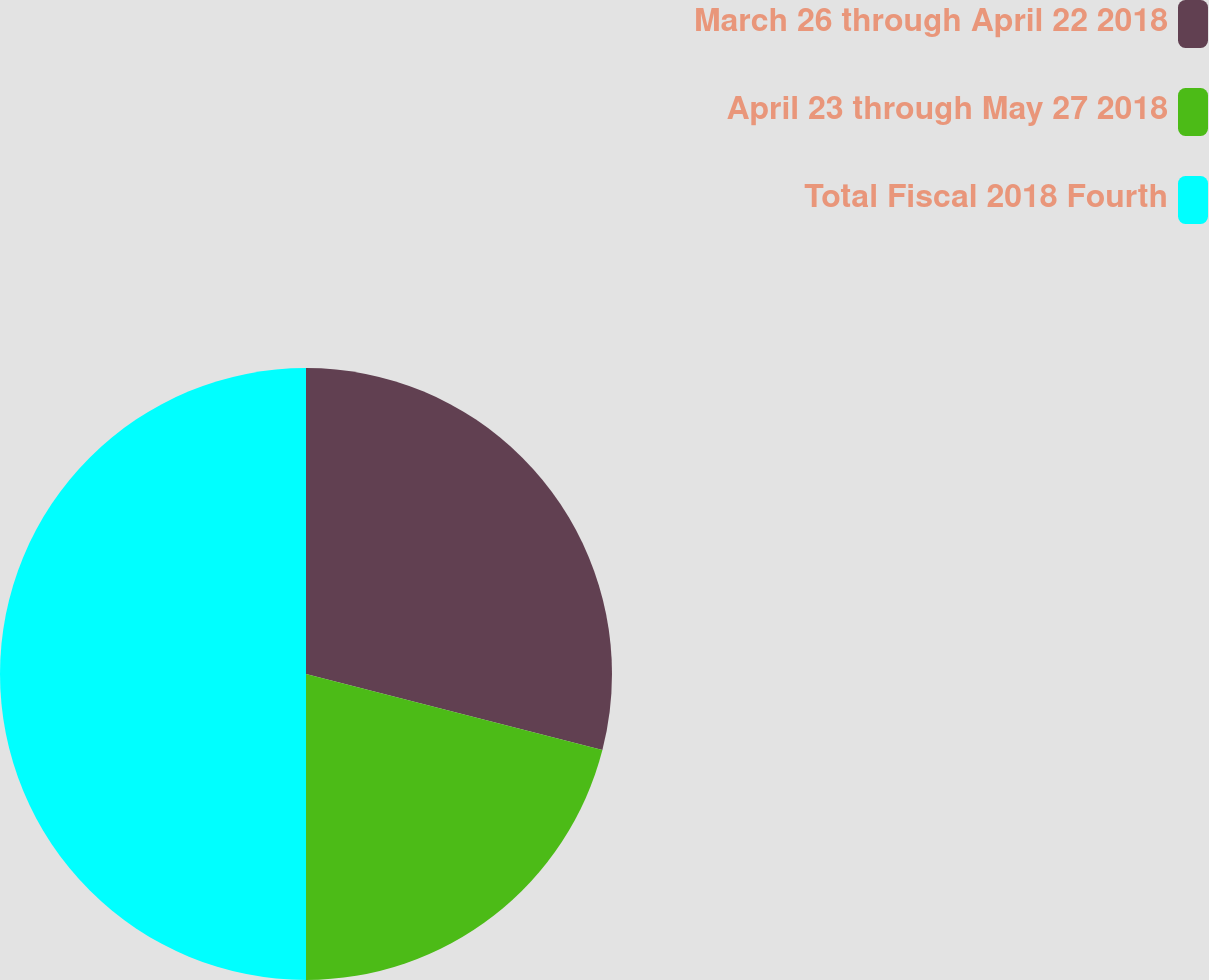<chart> <loc_0><loc_0><loc_500><loc_500><pie_chart><fcel>March 26 through April 22 2018<fcel>April 23 through May 27 2018<fcel>Total Fiscal 2018 Fourth<nl><fcel>29.0%<fcel>21.0%<fcel>50.0%<nl></chart> 